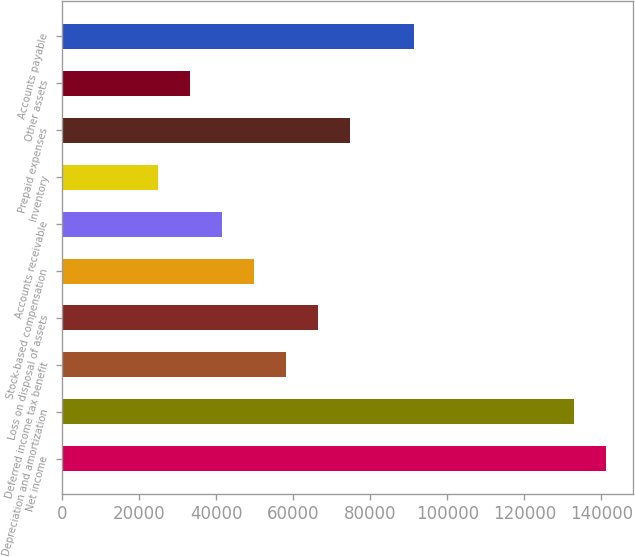Convert chart to OTSL. <chart><loc_0><loc_0><loc_500><loc_500><bar_chart><fcel>Net income<fcel>Depreciation and amortization<fcel>Deferred income tax benefit<fcel>Loss on disposal of assets<fcel>Stock-based compensation<fcel>Accounts receivable<fcel>Inventory<fcel>Prepaid expenses<fcel>Other assets<fcel>Accounts payable<nl><fcel>141150<fcel>132848<fcel>58130<fcel>66432<fcel>49828<fcel>41526<fcel>24922<fcel>74734<fcel>33224<fcel>91338<nl></chart> 